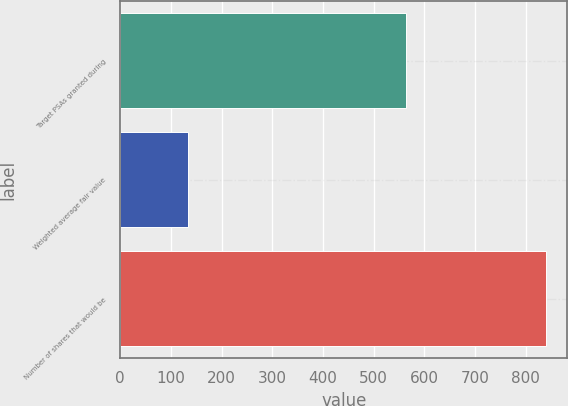<chart> <loc_0><loc_0><loc_500><loc_500><bar_chart><fcel>Target PSAs granted during<fcel>Weighted average fair value<fcel>Number of shares that would be<nl><fcel>564<fcel>134<fcel>840<nl></chart> 